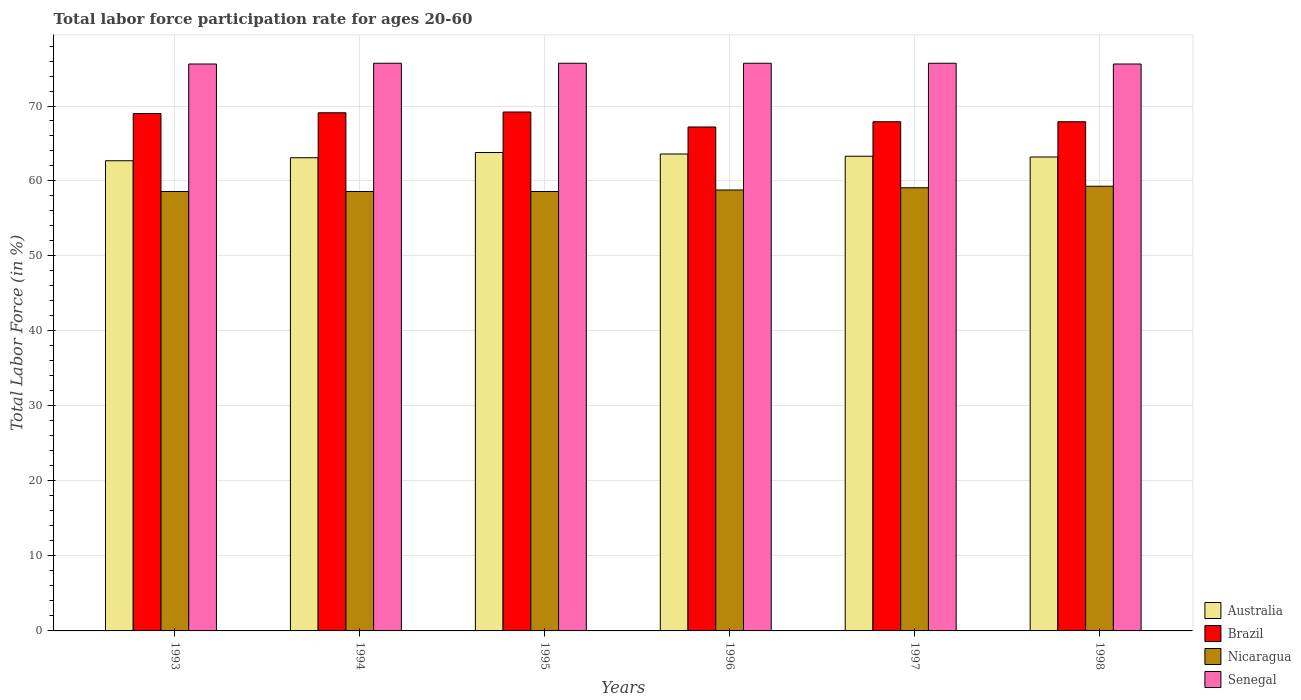How many different coloured bars are there?
Keep it short and to the point. 4. How many bars are there on the 5th tick from the left?
Keep it short and to the point. 4. What is the labor force participation rate in Senegal in 1998?
Offer a terse response. 75.6. Across all years, what is the maximum labor force participation rate in Senegal?
Your response must be concise. 75.7. Across all years, what is the minimum labor force participation rate in Australia?
Your answer should be compact. 62.7. In which year was the labor force participation rate in Nicaragua minimum?
Ensure brevity in your answer.  1993. What is the total labor force participation rate in Australia in the graph?
Your answer should be compact. 379.7. What is the difference between the labor force participation rate in Nicaragua in 1994 and that in 1996?
Offer a very short reply. -0.2. What is the difference between the labor force participation rate in Brazil in 1993 and the labor force participation rate in Australia in 1996?
Give a very brief answer. 5.4. What is the average labor force participation rate in Senegal per year?
Offer a terse response. 75.67. In the year 1995, what is the difference between the labor force participation rate in Nicaragua and labor force participation rate in Brazil?
Give a very brief answer. -10.6. What is the ratio of the labor force participation rate in Brazil in 1994 to that in 1996?
Your response must be concise. 1.03. What is the difference between the highest and the second highest labor force participation rate in Brazil?
Ensure brevity in your answer.  0.1. What is the difference between the highest and the lowest labor force participation rate in Australia?
Make the answer very short. 1.1. Is the sum of the labor force participation rate in Brazil in 1996 and 1998 greater than the maximum labor force participation rate in Nicaragua across all years?
Your answer should be compact. Yes. Is it the case that in every year, the sum of the labor force participation rate in Australia and labor force participation rate in Nicaragua is greater than the sum of labor force participation rate in Senegal and labor force participation rate in Brazil?
Your answer should be very brief. No. What does the 2nd bar from the left in 1995 represents?
Provide a short and direct response. Brazil. Is it the case that in every year, the sum of the labor force participation rate in Senegal and labor force participation rate in Australia is greater than the labor force participation rate in Brazil?
Keep it short and to the point. Yes. How many bars are there?
Give a very brief answer. 24. Does the graph contain grids?
Your answer should be very brief. Yes. Where does the legend appear in the graph?
Your answer should be very brief. Bottom right. How many legend labels are there?
Your answer should be very brief. 4. What is the title of the graph?
Your answer should be compact. Total labor force participation rate for ages 20-60. What is the label or title of the X-axis?
Give a very brief answer. Years. What is the label or title of the Y-axis?
Offer a very short reply. Total Labor Force (in %). What is the Total Labor Force (in %) of Australia in 1993?
Offer a terse response. 62.7. What is the Total Labor Force (in %) of Brazil in 1993?
Your answer should be compact. 69. What is the Total Labor Force (in %) of Nicaragua in 1993?
Provide a succinct answer. 58.6. What is the Total Labor Force (in %) of Senegal in 1993?
Provide a short and direct response. 75.6. What is the Total Labor Force (in %) in Australia in 1994?
Offer a very short reply. 63.1. What is the Total Labor Force (in %) of Brazil in 1994?
Your answer should be compact. 69.1. What is the Total Labor Force (in %) in Nicaragua in 1994?
Give a very brief answer. 58.6. What is the Total Labor Force (in %) in Senegal in 1994?
Offer a very short reply. 75.7. What is the Total Labor Force (in %) in Australia in 1995?
Ensure brevity in your answer.  63.8. What is the Total Labor Force (in %) of Brazil in 1995?
Provide a succinct answer. 69.2. What is the Total Labor Force (in %) in Nicaragua in 1995?
Offer a very short reply. 58.6. What is the Total Labor Force (in %) of Senegal in 1995?
Your answer should be compact. 75.7. What is the Total Labor Force (in %) in Australia in 1996?
Your answer should be compact. 63.6. What is the Total Labor Force (in %) in Brazil in 1996?
Ensure brevity in your answer.  67.2. What is the Total Labor Force (in %) in Nicaragua in 1996?
Offer a terse response. 58.8. What is the Total Labor Force (in %) of Senegal in 1996?
Ensure brevity in your answer.  75.7. What is the Total Labor Force (in %) of Australia in 1997?
Your answer should be compact. 63.3. What is the Total Labor Force (in %) in Brazil in 1997?
Give a very brief answer. 67.9. What is the Total Labor Force (in %) in Nicaragua in 1997?
Your response must be concise. 59.1. What is the Total Labor Force (in %) in Senegal in 1997?
Your answer should be very brief. 75.7. What is the Total Labor Force (in %) of Australia in 1998?
Your response must be concise. 63.2. What is the Total Labor Force (in %) of Brazil in 1998?
Make the answer very short. 67.9. What is the Total Labor Force (in %) in Nicaragua in 1998?
Your response must be concise. 59.3. What is the Total Labor Force (in %) of Senegal in 1998?
Your answer should be compact. 75.6. Across all years, what is the maximum Total Labor Force (in %) of Australia?
Give a very brief answer. 63.8. Across all years, what is the maximum Total Labor Force (in %) of Brazil?
Ensure brevity in your answer.  69.2. Across all years, what is the maximum Total Labor Force (in %) of Nicaragua?
Your answer should be very brief. 59.3. Across all years, what is the maximum Total Labor Force (in %) of Senegal?
Your answer should be compact. 75.7. Across all years, what is the minimum Total Labor Force (in %) in Australia?
Keep it short and to the point. 62.7. Across all years, what is the minimum Total Labor Force (in %) in Brazil?
Provide a short and direct response. 67.2. Across all years, what is the minimum Total Labor Force (in %) of Nicaragua?
Your answer should be compact. 58.6. Across all years, what is the minimum Total Labor Force (in %) of Senegal?
Provide a succinct answer. 75.6. What is the total Total Labor Force (in %) of Australia in the graph?
Keep it short and to the point. 379.7. What is the total Total Labor Force (in %) of Brazil in the graph?
Give a very brief answer. 410.3. What is the total Total Labor Force (in %) of Nicaragua in the graph?
Offer a very short reply. 353. What is the total Total Labor Force (in %) in Senegal in the graph?
Offer a terse response. 454. What is the difference between the Total Labor Force (in %) of Australia in 1993 and that in 1994?
Give a very brief answer. -0.4. What is the difference between the Total Labor Force (in %) in Senegal in 1993 and that in 1994?
Ensure brevity in your answer.  -0.1. What is the difference between the Total Labor Force (in %) of Brazil in 1993 and that in 1995?
Offer a very short reply. -0.2. What is the difference between the Total Labor Force (in %) in Senegal in 1993 and that in 1995?
Keep it short and to the point. -0.1. What is the difference between the Total Labor Force (in %) of Australia in 1993 and that in 1996?
Make the answer very short. -0.9. What is the difference between the Total Labor Force (in %) of Nicaragua in 1993 and that in 1996?
Provide a short and direct response. -0.2. What is the difference between the Total Labor Force (in %) in Brazil in 1993 and that in 1997?
Your answer should be very brief. 1.1. What is the difference between the Total Labor Force (in %) of Brazil in 1993 and that in 1998?
Offer a terse response. 1.1. What is the difference between the Total Labor Force (in %) in Senegal in 1993 and that in 1998?
Make the answer very short. 0. What is the difference between the Total Labor Force (in %) of Australia in 1994 and that in 1995?
Your answer should be very brief. -0.7. What is the difference between the Total Labor Force (in %) in Senegal in 1994 and that in 1995?
Offer a very short reply. 0. What is the difference between the Total Labor Force (in %) of Australia in 1994 and that in 1996?
Provide a succinct answer. -0.5. What is the difference between the Total Labor Force (in %) of Senegal in 1994 and that in 1996?
Offer a terse response. 0. What is the difference between the Total Labor Force (in %) in Brazil in 1994 and that in 1997?
Provide a succinct answer. 1.2. What is the difference between the Total Labor Force (in %) of Nicaragua in 1994 and that in 1997?
Offer a very short reply. -0.5. What is the difference between the Total Labor Force (in %) of Senegal in 1994 and that in 1997?
Provide a short and direct response. 0. What is the difference between the Total Labor Force (in %) of Australia in 1994 and that in 1998?
Your answer should be compact. -0.1. What is the difference between the Total Labor Force (in %) in Nicaragua in 1994 and that in 1998?
Offer a very short reply. -0.7. What is the difference between the Total Labor Force (in %) of Nicaragua in 1995 and that in 1997?
Offer a terse response. -0.5. What is the difference between the Total Labor Force (in %) of Senegal in 1995 and that in 1997?
Offer a very short reply. 0. What is the difference between the Total Labor Force (in %) in Brazil in 1995 and that in 1998?
Provide a succinct answer. 1.3. What is the difference between the Total Labor Force (in %) of Australia in 1996 and that in 1997?
Provide a succinct answer. 0.3. What is the difference between the Total Labor Force (in %) in Nicaragua in 1996 and that in 1997?
Your answer should be very brief. -0.3. What is the difference between the Total Labor Force (in %) of Australia in 1996 and that in 1998?
Offer a terse response. 0.4. What is the difference between the Total Labor Force (in %) of Brazil in 1996 and that in 1998?
Offer a very short reply. -0.7. What is the difference between the Total Labor Force (in %) of Australia in 1997 and that in 1998?
Your answer should be very brief. 0.1. What is the difference between the Total Labor Force (in %) in Brazil in 1997 and that in 1998?
Make the answer very short. 0. What is the difference between the Total Labor Force (in %) of Australia in 1993 and the Total Labor Force (in %) of Brazil in 1994?
Ensure brevity in your answer.  -6.4. What is the difference between the Total Labor Force (in %) in Brazil in 1993 and the Total Labor Force (in %) in Nicaragua in 1994?
Ensure brevity in your answer.  10.4. What is the difference between the Total Labor Force (in %) in Nicaragua in 1993 and the Total Labor Force (in %) in Senegal in 1994?
Offer a very short reply. -17.1. What is the difference between the Total Labor Force (in %) in Australia in 1993 and the Total Labor Force (in %) in Nicaragua in 1995?
Give a very brief answer. 4.1. What is the difference between the Total Labor Force (in %) in Australia in 1993 and the Total Labor Force (in %) in Senegal in 1995?
Your answer should be compact. -13. What is the difference between the Total Labor Force (in %) in Brazil in 1993 and the Total Labor Force (in %) in Nicaragua in 1995?
Your response must be concise. 10.4. What is the difference between the Total Labor Force (in %) of Nicaragua in 1993 and the Total Labor Force (in %) of Senegal in 1995?
Provide a short and direct response. -17.1. What is the difference between the Total Labor Force (in %) of Australia in 1993 and the Total Labor Force (in %) of Brazil in 1996?
Give a very brief answer. -4.5. What is the difference between the Total Labor Force (in %) of Australia in 1993 and the Total Labor Force (in %) of Senegal in 1996?
Give a very brief answer. -13. What is the difference between the Total Labor Force (in %) of Brazil in 1993 and the Total Labor Force (in %) of Nicaragua in 1996?
Keep it short and to the point. 10.2. What is the difference between the Total Labor Force (in %) in Brazil in 1993 and the Total Labor Force (in %) in Senegal in 1996?
Your answer should be very brief. -6.7. What is the difference between the Total Labor Force (in %) in Nicaragua in 1993 and the Total Labor Force (in %) in Senegal in 1996?
Your answer should be compact. -17.1. What is the difference between the Total Labor Force (in %) of Australia in 1993 and the Total Labor Force (in %) of Brazil in 1997?
Your answer should be very brief. -5.2. What is the difference between the Total Labor Force (in %) of Australia in 1993 and the Total Labor Force (in %) of Nicaragua in 1997?
Your answer should be very brief. 3.6. What is the difference between the Total Labor Force (in %) of Brazil in 1993 and the Total Labor Force (in %) of Senegal in 1997?
Offer a terse response. -6.7. What is the difference between the Total Labor Force (in %) of Nicaragua in 1993 and the Total Labor Force (in %) of Senegal in 1997?
Provide a succinct answer. -17.1. What is the difference between the Total Labor Force (in %) of Australia in 1993 and the Total Labor Force (in %) of Brazil in 1998?
Provide a short and direct response. -5.2. What is the difference between the Total Labor Force (in %) in Australia in 1994 and the Total Labor Force (in %) in Brazil in 1995?
Offer a very short reply. -6.1. What is the difference between the Total Labor Force (in %) of Australia in 1994 and the Total Labor Force (in %) of Nicaragua in 1995?
Your answer should be compact. 4.5. What is the difference between the Total Labor Force (in %) of Brazil in 1994 and the Total Labor Force (in %) of Nicaragua in 1995?
Give a very brief answer. 10.5. What is the difference between the Total Labor Force (in %) of Brazil in 1994 and the Total Labor Force (in %) of Senegal in 1995?
Keep it short and to the point. -6.6. What is the difference between the Total Labor Force (in %) in Nicaragua in 1994 and the Total Labor Force (in %) in Senegal in 1995?
Provide a succinct answer. -17.1. What is the difference between the Total Labor Force (in %) in Australia in 1994 and the Total Labor Force (in %) in Brazil in 1996?
Offer a terse response. -4.1. What is the difference between the Total Labor Force (in %) of Brazil in 1994 and the Total Labor Force (in %) of Senegal in 1996?
Provide a succinct answer. -6.6. What is the difference between the Total Labor Force (in %) of Nicaragua in 1994 and the Total Labor Force (in %) of Senegal in 1996?
Offer a very short reply. -17.1. What is the difference between the Total Labor Force (in %) in Australia in 1994 and the Total Labor Force (in %) in Nicaragua in 1997?
Give a very brief answer. 4. What is the difference between the Total Labor Force (in %) of Australia in 1994 and the Total Labor Force (in %) of Senegal in 1997?
Provide a succinct answer. -12.6. What is the difference between the Total Labor Force (in %) in Brazil in 1994 and the Total Labor Force (in %) in Senegal in 1997?
Ensure brevity in your answer.  -6.6. What is the difference between the Total Labor Force (in %) in Nicaragua in 1994 and the Total Labor Force (in %) in Senegal in 1997?
Make the answer very short. -17.1. What is the difference between the Total Labor Force (in %) of Brazil in 1994 and the Total Labor Force (in %) of Nicaragua in 1998?
Provide a succinct answer. 9.8. What is the difference between the Total Labor Force (in %) of Brazil in 1994 and the Total Labor Force (in %) of Senegal in 1998?
Make the answer very short. -6.5. What is the difference between the Total Labor Force (in %) of Nicaragua in 1994 and the Total Labor Force (in %) of Senegal in 1998?
Provide a succinct answer. -17. What is the difference between the Total Labor Force (in %) in Brazil in 1995 and the Total Labor Force (in %) in Senegal in 1996?
Make the answer very short. -6.5. What is the difference between the Total Labor Force (in %) of Nicaragua in 1995 and the Total Labor Force (in %) of Senegal in 1996?
Your response must be concise. -17.1. What is the difference between the Total Labor Force (in %) in Australia in 1995 and the Total Labor Force (in %) in Nicaragua in 1997?
Provide a short and direct response. 4.7. What is the difference between the Total Labor Force (in %) of Australia in 1995 and the Total Labor Force (in %) of Senegal in 1997?
Offer a very short reply. -11.9. What is the difference between the Total Labor Force (in %) in Nicaragua in 1995 and the Total Labor Force (in %) in Senegal in 1997?
Provide a short and direct response. -17.1. What is the difference between the Total Labor Force (in %) in Australia in 1995 and the Total Labor Force (in %) in Nicaragua in 1998?
Give a very brief answer. 4.5. What is the difference between the Total Labor Force (in %) of Brazil in 1995 and the Total Labor Force (in %) of Nicaragua in 1998?
Provide a short and direct response. 9.9. What is the difference between the Total Labor Force (in %) of Brazil in 1995 and the Total Labor Force (in %) of Senegal in 1998?
Your response must be concise. -6.4. What is the difference between the Total Labor Force (in %) of Nicaragua in 1995 and the Total Labor Force (in %) of Senegal in 1998?
Make the answer very short. -17. What is the difference between the Total Labor Force (in %) in Australia in 1996 and the Total Labor Force (in %) in Senegal in 1997?
Provide a succinct answer. -12.1. What is the difference between the Total Labor Force (in %) in Brazil in 1996 and the Total Labor Force (in %) in Senegal in 1997?
Your answer should be compact. -8.5. What is the difference between the Total Labor Force (in %) of Nicaragua in 1996 and the Total Labor Force (in %) of Senegal in 1997?
Offer a very short reply. -16.9. What is the difference between the Total Labor Force (in %) of Nicaragua in 1996 and the Total Labor Force (in %) of Senegal in 1998?
Provide a short and direct response. -16.8. What is the difference between the Total Labor Force (in %) in Brazil in 1997 and the Total Labor Force (in %) in Nicaragua in 1998?
Keep it short and to the point. 8.6. What is the difference between the Total Labor Force (in %) of Brazil in 1997 and the Total Labor Force (in %) of Senegal in 1998?
Offer a terse response. -7.7. What is the difference between the Total Labor Force (in %) in Nicaragua in 1997 and the Total Labor Force (in %) in Senegal in 1998?
Ensure brevity in your answer.  -16.5. What is the average Total Labor Force (in %) in Australia per year?
Offer a terse response. 63.28. What is the average Total Labor Force (in %) in Brazil per year?
Provide a succinct answer. 68.38. What is the average Total Labor Force (in %) of Nicaragua per year?
Your answer should be compact. 58.83. What is the average Total Labor Force (in %) in Senegal per year?
Offer a very short reply. 75.67. In the year 1993, what is the difference between the Total Labor Force (in %) in Australia and Total Labor Force (in %) in Senegal?
Ensure brevity in your answer.  -12.9. In the year 1993, what is the difference between the Total Labor Force (in %) of Nicaragua and Total Labor Force (in %) of Senegal?
Make the answer very short. -17. In the year 1994, what is the difference between the Total Labor Force (in %) in Brazil and Total Labor Force (in %) in Senegal?
Ensure brevity in your answer.  -6.6. In the year 1994, what is the difference between the Total Labor Force (in %) of Nicaragua and Total Labor Force (in %) of Senegal?
Provide a short and direct response. -17.1. In the year 1995, what is the difference between the Total Labor Force (in %) in Australia and Total Labor Force (in %) in Brazil?
Keep it short and to the point. -5.4. In the year 1995, what is the difference between the Total Labor Force (in %) of Australia and Total Labor Force (in %) of Nicaragua?
Offer a very short reply. 5.2. In the year 1995, what is the difference between the Total Labor Force (in %) in Australia and Total Labor Force (in %) in Senegal?
Provide a succinct answer. -11.9. In the year 1995, what is the difference between the Total Labor Force (in %) of Nicaragua and Total Labor Force (in %) of Senegal?
Provide a succinct answer. -17.1. In the year 1996, what is the difference between the Total Labor Force (in %) in Australia and Total Labor Force (in %) in Senegal?
Make the answer very short. -12.1. In the year 1996, what is the difference between the Total Labor Force (in %) of Brazil and Total Labor Force (in %) of Nicaragua?
Keep it short and to the point. 8.4. In the year 1996, what is the difference between the Total Labor Force (in %) of Nicaragua and Total Labor Force (in %) of Senegal?
Your answer should be very brief. -16.9. In the year 1997, what is the difference between the Total Labor Force (in %) of Brazil and Total Labor Force (in %) of Senegal?
Your answer should be very brief. -7.8. In the year 1997, what is the difference between the Total Labor Force (in %) in Nicaragua and Total Labor Force (in %) in Senegal?
Your answer should be very brief. -16.6. In the year 1998, what is the difference between the Total Labor Force (in %) in Australia and Total Labor Force (in %) in Brazil?
Your response must be concise. -4.7. In the year 1998, what is the difference between the Total Labor Force (in %) of Australia and Total Labor Force (in %) of Nicaragua?
Offer a very short reply. 3.9. In the year 1998, what is the difference between the Total Labor Force (in %) in Brazil and Total Labor Force (in %) in Nicaragua?
Offer a very short reply. 8.6. In the year 1998, what is the difference between the Total Labor Force (in %) of Brazil and Total Labor Force (in %) of Senegal?
Make the answer very short. -7.7. In the year 1998, what is the difference between the Total Labor Force (in %) of Nicaragua and Total Labor Force (in %) of Senegal?
Provide a short and direct response. -16.3. What is the ratio of the Total Labor Force (in %) in Australia in 1993 to that in 1994?
Your answer should be compact. 0.99. What is the ratio of the Total Labor Force (in %) in Nicaragua in 1993 to that in 1994?
Your answer should be very brief. 1. What is the ratio of the Total Labor Force (in %) in Australia in 1993 to that in 1995?
Offer a very short reply. 0.98. What is the ratio of the Total Labor Force (in %) of Brazil in 1993 to that in 1995?
Provide a succinct answer. 1. What is the ratio of the Total Labor Force (in %) in Australia in 1993 to that in 1996?
Ensure brevity in your answer.  0.99. What is the ratio of the Total Labor Force (in %) in Brazil in 1993 to that in 1996?
Ensure brevity in your answer.  1.03. What is the ratio of the Total Labor Force (in %) of Senegal in 1993 to that in 1996?
Offer a very short reply. 1. What is the ratio of the Total Labor Force (in %) of Brazil in 1993 to that in 1997?
Ensure brevity in your answer.  1.02. What is the ratio of the Total Labor Force (in %) in Australia in 1993 to that in 1998?
Give a very brief answer. 0.99. What is the ratio of the Total Labor Force (in %) of Brazil in 1993 to that in 1998?
Offer a very short reply. 1.02. What is the ratio of the Total Labor Force (in %) in Nicaragua in 1993 to that in 1998?
Offer a terse response. 0.99. What is the ratio of the Total Labor Force (in %) in Nicaragua in 1994 to that in 1995?
Give a very brief answer. 1. What is the ratio of the Total Labor Force (in %) of Senegal in 1994 to that in 1995?
Your response must be concise. 1. What is the ratio of the Total Labor Force (in %) in Brazil in 1994 to that in 1996?
Provide a succinct answer. 1.03. What is the ratio of the Total Labor Force (in %) of Nicaragua in 1994 to that in 1996?
Offer a very short reply. 1. What is the ratio of the Total Labor Force (in %) in Brazil in 1994 to that in 1997?
Ensure brevity in your answer.  1.02. What is the ratio of the Total Labor Force (in %) in Senegal in 1994 to that in 1997?
Your answer should be very brief. 1. What is the ratio of the Total Labor Force (in %) of Brazil in 1994 to that in 1998?
Ensure brevity in your answer.  1.02. What is the ratio of the Total Labor Force (in %) of Nicaragua in 1994 to that in 1998?
Your answer should be very brief. 0.99. What is the ratio of the Total Labor Force (in %) of Australia in 1995 to that in 1996?
Your response must be concise. 1. What is the ratio of the Total Labor Force (in %) of Brazil in 1995 to that in 1996?
Your answer should be compact. 1.03. What is the ratio of the Total Labor Force (in %) in Nicaragua in 1995 to that in 1996?
Give a very brief answer. 1. What is the ratio of the Total Labor Force (in %) of Australia in 1995 to that in 1997?
Provide a short and direct response. 1.01. What is the ratio of the Total Labor Force (in %) of Brazil in 1995 to that in 1997?
Offer a terse response. 1.02. What is the ratio of the Total Labor Force (in %) of Senegal in 1995 to that in 1997?
Your response must be concise. 1. What is the ratio of the Total Labor Force (in %) in Australia in 1995 to that in 1998?
Your answer should be compact. 1.01. What is the ratio of the Total Labor Force (in %) in Brazil in 1995 to that in 1998?
Give a very brief answer. 1.02. What is the ratio of the Total Labor Force (in %) in Senegal in 1995 to that in 1998?
Keep it short and to the point. 1. What is the ratio of the Total Labor Force (in %) in Australia in 1996 to that in 1997?
Your response must be concise. 1. What is the ratio of the Total Labor Force (in %) of Brazil in 1996 to that in 1997?
Your answer should be compact. 0.99. What is the ratio of the Total Labor Force (in %) in Senegal in 1996 to that in 1997?
Make the answer very short. 1. What is the ratio of the Total Labor Force (in %) in Nicaragua in 1996 to that in 1998?
Make the answer very short. 0.99. What is the ratio of the Total Labor Force (in %) of Senegal in 1996 to that in 1998?
Keep it short and to the point. 1. What is the ratio of the Total Labor Force (in %) of Brazil in 1997 to that in 1998?
Your answer should be compact. 1. What is the difference between the highest and the second highest Total Labor Force (in %) in Australia?
Provide a short and direct response. 0.2. What is the difference between the highest and the second highest Total Labor Force (in %) in Brazil?
Offer a terse response. 0.1. What is the difference between the highest and the second highest Total Labor Force (in %) in Senegal?
Your response must be concise. 0. What is the difference between the highest and the lowest Total Labor Force (in %) of Australia?
Ensure brevity in your answer.  1.1. What is the difference between the highest and the lowest Total Labor Force (in %) of Brazil?
Give a very brief answer. 2. What is the difference between the highest and the lowest Total Labor Force (in %) in Nicaragua?
Your answer should be very brief. 0.7. What is the difference between the highest and the lowest Total Labor Force (in %) of Senegal?
Give a very brief answer. 0.1. 